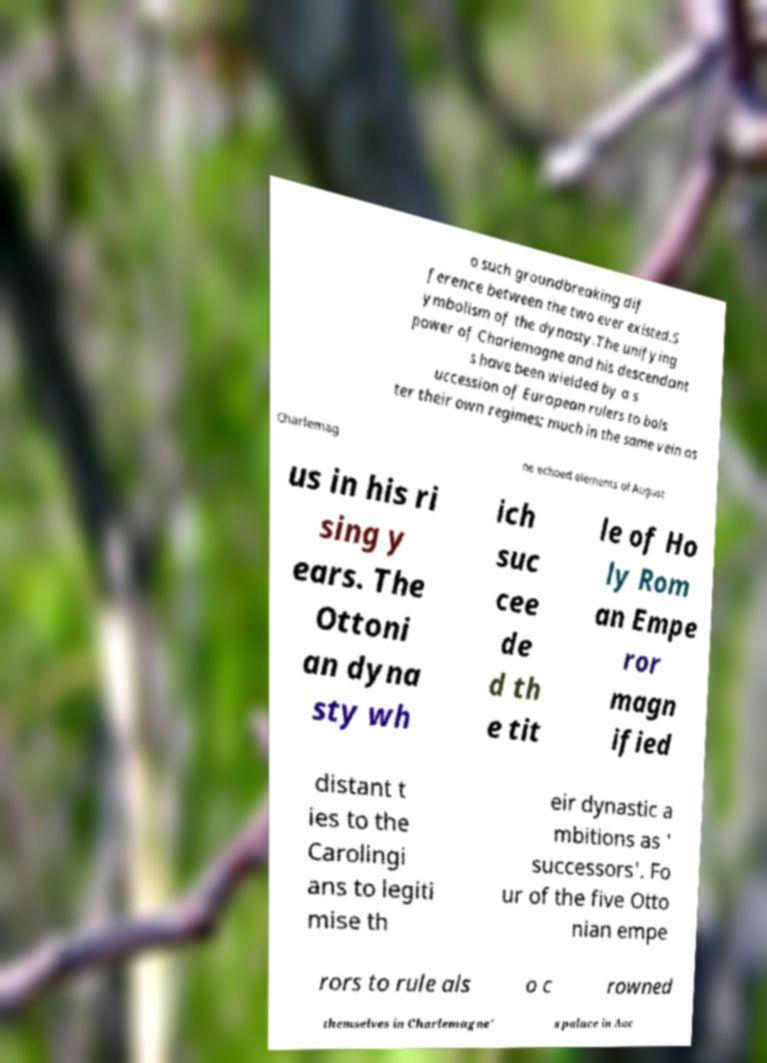For documentation purposes, I need the text within this image transcribed. Could you provide that? o such groundbreaking dif ference between the two ever existed.S ymbolism of the dynasty.The unifying power of Charlemagne and his descendant s have been wielded by a s uccession of European rulers to bols ter their own regimes; much in the same vein as Charlemag ne echoed elements of August us in his ri sing y ears. The Ottoni an dyna sty wh ich suc cee de d th e tit le of Ho ly Rom an Empe ror magn ified distant t ies to the Carolingi ans to legiti mise th eir dynastic a mbitions as ' successors'. Fo ur of the five Otto nian empe rors to rule als o c rowned themselves in Charlemagne' s palace in Aac 